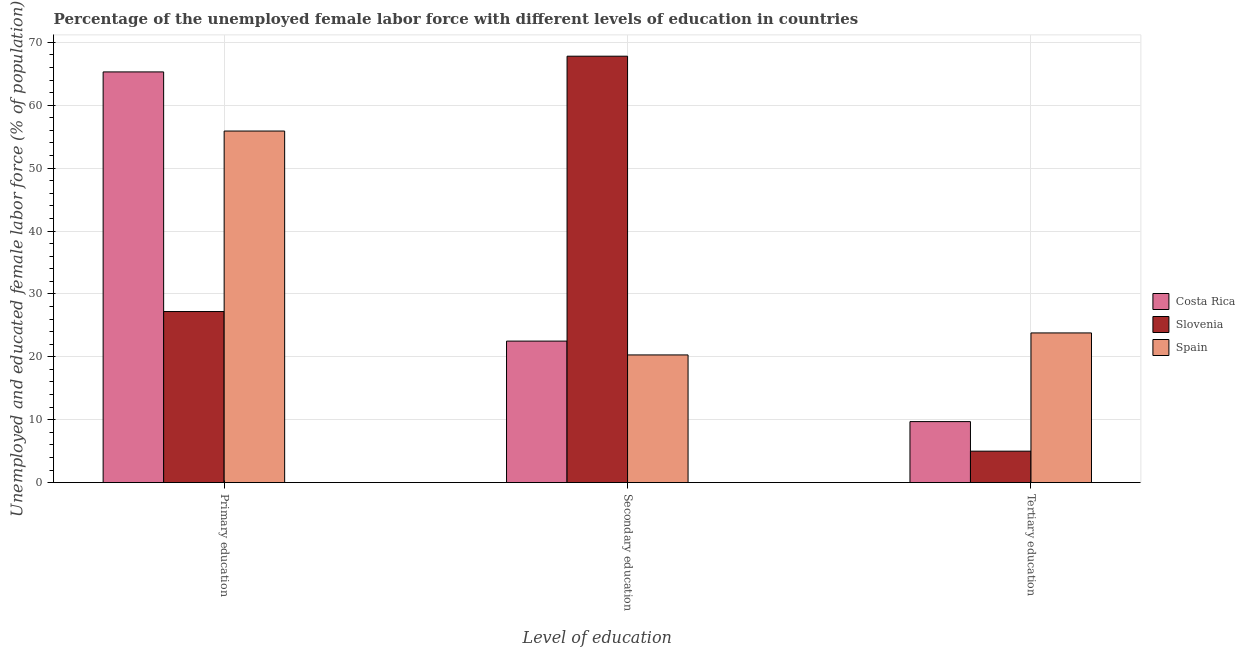How many different coloured bars are there?
Offer a very short reply. 3. How many groups of bars are there?
Offer a terse response. 3. Are the number of bars per tick equal to the number of legend labels?
Offer a terse response. Yes. How many bars are there on the 3rd tick from the right?
Offer a very short reply. 3. What is the label of the 3rd group of bars from the left?
Ensure brevity in your answer.  Tertiary education. What is the percentage of female labor force who received primary education in Slovenia?
Give a very brief answer. 27.2. Across all countries, what is the maximum percentage of female labor force who received primary education?
Offer a very short reply. 65.3. In which country was the percentage of female labor force who received tertiary education maximum?
Ensure brevity in your answer.  Spain. In which country was the percentage of female labor force who received primary education minimum?
Your response must be concise. Slovenia. What is the total percentage of female labor force who received primary education in the graph?
Your response must be concise. 148.4. What is the difference between the percentage of female labor force who received primary education in Costa Rica and that in Spain?
Provide a short and direct response. 9.4. What is the difference between the percentage of female labor force who received tertiary education in Slovenia and the percentage of female labor force who received secondary education in Costa Rica?
Give a very brief answer. -17.5. What is the average percentage of female labor force who received secondary education per country?
Ensure brevity in your answer.  36.87. What is the difference between the percentage of female labor force who received primary education and percentage of female labor force who received tertiary education in Slovenia?
Make the answer very short. 22.2. What is the ratio of the percentage of female labor force who received tertiary education in Slovenia to that in Spain?
Offer a terse response. 0.21. Is the percentage of female labor force who received tertiary education in Costa Rica less than that in Spain?
Provide a succinct answer. Yes. Is the difference between the percentage of female labor force who received primary education in Slovenia and Costa Rica greater than the difference between the percentage of female labor force who received secondary education in Slovenia and Costa Rica?
Your answer should be compact. No. What is the difference between the highest and the second highest percentage of female labor force who received secondary education?
Provide a short and direct response. 45.3. What is the difference between the highest and the lowest percentage of female labor force who received primary education?
Provide a short and direct response. 38.1. Is it the case that in every country, the sum of the percentage of female labor force who received primary education and percentage of female labor force who received secondary education is greater than the percentage of female labor force who received tertiary education?
Your response must be concise. Yes. How many bars are there?
Keep it short and to the point. 9. Are all the bars in the graph horizontal?
Give a very brief answer. No. What is the difference between two consecutive major ticks on the Y-axis?
Offer a very short reply. 10. Does the graph contain any zero values?
Offer a very short reply. No. Where does the legend appear in the graph?
Offer a terse response. Center right. How many legend labels are there?
Make the answer very short. 3. How are the legend labels stacked?
Keep it short and to the point. Vertical. What is the title of the graph?
Your answer should be compact. Percentage of the unemployed female labor force with different levels of education in countries. What is the label or title of the X-axis?
Offer a very short reply. Level of education. What is the label or title of the Y-axis?
Your response must be concise. Unemployed and educated female labor force (% of population). What is the Unemployed and educated female labor force (% of population) in Costa Rica in Primary education?
Offer a terse response. 65.3. What is the Unemployed and educated female labor force (% of population) of Slovenia in Primary education?
Provide a succinct answer. 27.2. What is the Unemployed and educated female labor force (% of population) of Spain in Primary education?
Keep it short and to the point. 55.9. What is the Unemployed and educated female labor force (% of population) in Slovenia in Secondary education?
Keep it short and to the point. 67.8. What is the Unemployed and educated female labor force (% of population) of Spain in Secondary education?
Offer a very short reply. 20.3. What is the Unemployed and educated female labor force (% of population) of Costa Rica in Tertiary education?
Your answer should be compact. 9.7. What is the Unemployed and educated female labor force (% of population) of Spain in Tertiary education?
Your answer should be very brief. 23.8. Across all Level of education, what is the maximum Unemployed and educated female labor force (% of population) in Costa Rica?
Offer a very short reply. 65.3. Across all Level of education, what is the maximum Unemployed and educated female labor force (% of population) in Slovenia?
Your response must be concise. 67.8. Across all Level of education, what is the maximum Unemployed and educated female labor force (% of population) in Spain?
Provide a succinct answer. 55.9. Across all Level of education, what is the minimum Unemployed and educated female labor force (% of population) in Costa Rica?
Make the answer very short. 9.7. Across all Level of education, what is the minimum Unemployed and educated female labor force (% of population) in Spain?
Keep it short and to the point. 20.3. What is the total Unemployed and educated female labor force (% of population) of Costa Rica in the graph?
Offer a terse response. 97.5. What is the total Unemployed and educated female labor force (% of population) of Slovenia in the graph?
Offer a very short reply. 100. What is the difference between the Unemployed and educated female labor force (% of population) in Costa Rica in Primary education and that in Secondary education?
Ensure brevity in your answer.  42.8. What is the difference between the Unemployed and educated female labor force (% of population) in Slovenia in Primary education and that in Secondary education?
Your response must be concise. -40.6. What is the difference between the Unemployed and educated female labor force (% of population) of Spain in Primary education and that in Secondary education?
Give a very brief answer. 35.6. What is the difference between the Unemployed and educated female labor force (% of population) in Costa Rica in Primary education and that in Tertiary education?
Your answer should be compact. 55.6. What is the difference between the Unemployed and educated female labor force (% of population) in Slovenia in Primary education and that in Tertiary education?
Make the answer very short. 22.2. What is the difference between the Unemployed and educated female labor force (% of population) in Spain in Primary education and that in Tertiary education?
Provide a succinct answer. 32.1. What is the difference between the Unemployed and educated female labor force (% of population) in Slovenia in Secondary education and that in Tertiary education?
Offer a terse response. 62.8. What is the difference between the Unemployed and educated female labor force (% of population) of Costa Rica in Primary education and the Unemployed and educated female labor force (% of population) of Spain in Secondary education?
Offer a terse response. 45. What is the difference between the Unemployed and educated female labor force (% of population) in Costa Rica in Primary education and the Unemployed and educated female labor force (% of population) in Slovenia in Tertiary education?
Offer a very short reply. 60.3. What is the difference between the Unemployed and educated female labor force (% of population) of Costa Rica in Primary education and the Unemployed and educated female labor force (% of population) of Spain in Tertiary education?
Keep it short and to the point. 41.5. What is the difference between the Unemployed and educated female labor force (% of population) of Slovenia in Primary education and the Unemployed and educated female labor force (% of population) of Spain in Tertiary education?
Ensure brevity in your answer.  3.4. What is the difference between the Unemployed and educated female labor force (% of population) in Costa Rica in Secondary education and the Unemployed and educated female labor force (% of population) in Spain in Tertiary education?
Your response must be concise. -1.3. What is the average Unemployed and educated female labor force (% of population) in Costa Rica per Level of education?
Keep it short and to the point. 32.5. What is the average Unemployed and educated female labor force (% of population) in Slovenia per Level of education?
Provide a short and direct response. 33.33. What is the average Unemployed and educated female labor force (% of population) in Spain per Level of education?
Provide a succinct answer. 33.33. What is the difference between the Unemployed and educated female labor force (% of population) in Costa Rica and Unemployed and educated female labor force (% of population) in Slovenia in Primary education?
Your answer should be very brief. 38.1. What is the difference between the Unemployed and educated female labor force (% of population) of Costa Rica and Unemployed and educated female labor force (% of population) of Spain in Primary education?
Ensure brevity in your answer.  9.4. What is the difference between the Unemployed and educated female labor force (% of population) of Slovenia and Unemployed and educated female labor force (% of population) of Spain in Primary education?
Your answer should be compact. -28.7. What is the difference between the Unemployed and educated female labor force (% of population) of Costa Rica and Unemployed and educated female labor force (% of population) of Slovenia in Secondary education?
Your response must be concise. -45.3. What is the difference between the Unemployed and educated female labor force (% of population) in Costa Rica and Unemployed and educated female labor force (% of population) in Spain in Secondary education?
Offer a very short reply. 2.2. What is the difference between the Unemployed and educated female labor force (% of population) of Slovenia and Unemployed and educated female labor force (% of population) of Spain in Secondary education?
Ensure brevity in your answer.  47.5. What is the difference between the Unemployed and educated female labor force (% of population) in Costa Rica and Unemployed and educated female labor force (% of population) in Spain in Tertiary education?
Provide a succinct answer. -14.1. What is the difference between the Unemployed and educated female labor force (% of population) of Slovenia and Unemployed and educated female labor force (% of population) of Spain in Tertiary education?
Make the answer very short. -18.8. What is the ratio of the Unemployed and educated female labor force (% of population) of Costa Rica in Primary education to that in Secondary education?
Your response must be concise. 2.9. What is the ratio of the Unemployed and educated female labor force (% of population) of Slovenia in Primary education to that in Secondary education?
Keep it short and to the point. 0.4. What is the ratio of the Unemployed and educated female labor force (% of population) of Spain in Primary education to that in Secondary education?
Your response must be concise. 2.75. What is the ratio of the Unemployed and educated female labor force (% of population) of Costa Rica in Primary education to that in Tertiary education?
Your answer should be compact. 6.73. What is the ratio of the Unemployed and educated female labor force (% of population) in Slovenia in Primary education to that in Tertiary education?
Make the answer very short. 5.44. What is the ratio of the Unemployed and educated female labor force (% of population) in Spain in Primary education to that in Tertiary education?
Keep it short and to the point. 2.35. What is the ratio of the Unemployed and educated female labor force (% of population) in Costa Rica in Secondary education to that in Tertiary education?
Make the answer very short. 2.32. What is the ratio of the Unemployed and educated female labor force (% of population) of Slovenia in Secondary education to that in Tertiary education?
Give a very brief answer. 13.56. What is the ratio of the Unemployed and educated female labor force (% of population) in Spain in Secondary education to that in Tertiary education?
Offer a terse response. 0.85. What is the difference between the highest and the second highest Unemployed and educated female labor force (% of population) of Costa Rica?
Provide a short and direct response. 42.8. What is the difference between the highest and the second highest Unemployed and educated female labor force (% of population) in Slovenia?
Provide a short and direct response. 40.6. What is the difference between the highest and the second highest Unemployed and educated female labor force (% of population) in Spain?
Your answer should be very brief. 32.1. What is the difference between the highest and the lowest Unemployed and educated female labor force (% of population) of Costa Rica?
Provide a short and direct response. 55.6. What is the difference between the highest and the lowest Unemployed and educated female labor force (% of population) in Slovenia?
Your answer should be very brief. 62.8. What is the difference between the highest and the lowest Unemployed and educated female labor force (% of population) of Spain?
Your answer should be compact. 35.6. 